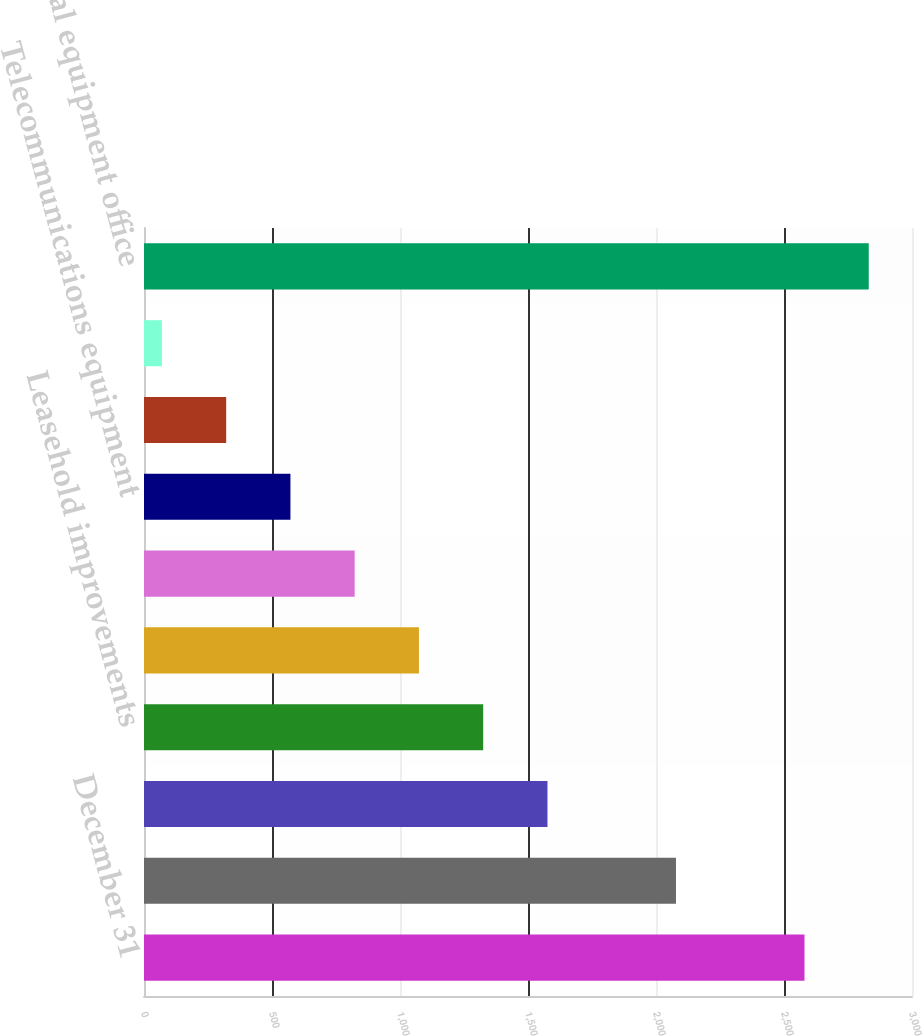<chart> <loc_0><loc_0><loc_500><loc_500><bar_chart><fcel>December 31<fcel>Software<fcel>Buildings<fcel>Leasehold improvements<fcel>Information technology<fcel>Furniture and equipment<fcel>Telecommunications equipment<fcel>Construction in progress<fcel>Land<fcel>Total equipment office<nl><fcel>2580<fcel>2078<fcel>1576<fcel>1325<fcel>1074<fcel>823<fcel>572<fcel>321<fcel>70<fcel>2831<nl></chart> 